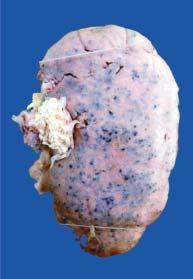what is the kidney enlarged in?
Answer the question using a single word or phrase. Size and weight 